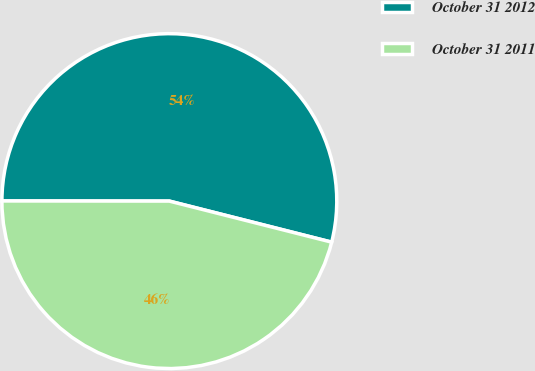Convert chart to OTSL. <chart><loc_0><loc_0><loc_500><loc_500><pie_chart><fcel>October 31 2012<fcel>October 31 2011<nl><fcel>53.93%<fcel>46.07%<nl></chart> 